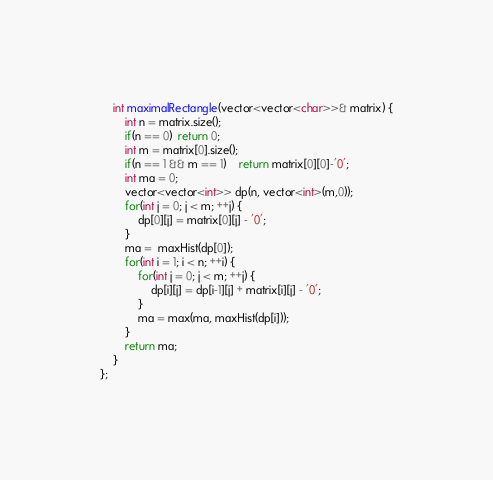<code> <loc_0><loc_0><loc_500><loc_500><_C++_>    int maximalRectangle(vector<vector<char>>& matrix) {
        int n = matrix.size();
        if(n == 0)  return 0;
        int m = matrix[0].size();
        if(n == 1 && m == 1)    return matrix[0][0]-'0';
        int ma = 0;
        vector<vector<int>> dp(n, vector<int>(m,0));
        for(int j = 0; j < m; ++j) {
            dp[0][j] = matrix[0][j] - '0';
        }
        ma =  maxHist(dp[0]);
        for(int i = 1; i < n; ++i) {
            for(int j = 0; j < m; ++j) {
                dp[i][j] = dp[i-1][j] + matrix[i][j] - '0';
            }
            ma = max(ma, maxHist(dp[i]));
        }
        return ma;
    }
};
</code> 